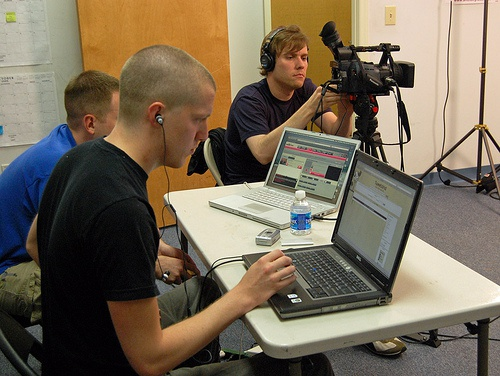Describe the objects in this image and their specific colors. I can see people in lightgray, black, maroon, and gray tones, laptop in lightgray, gray, and black tones, people in lightgray, black, navy, olive, and blue tones, people in lightgray, black, maroon, and gray tones, and laptop in lightgray, gray, darkgray, and beige tones in this image. 